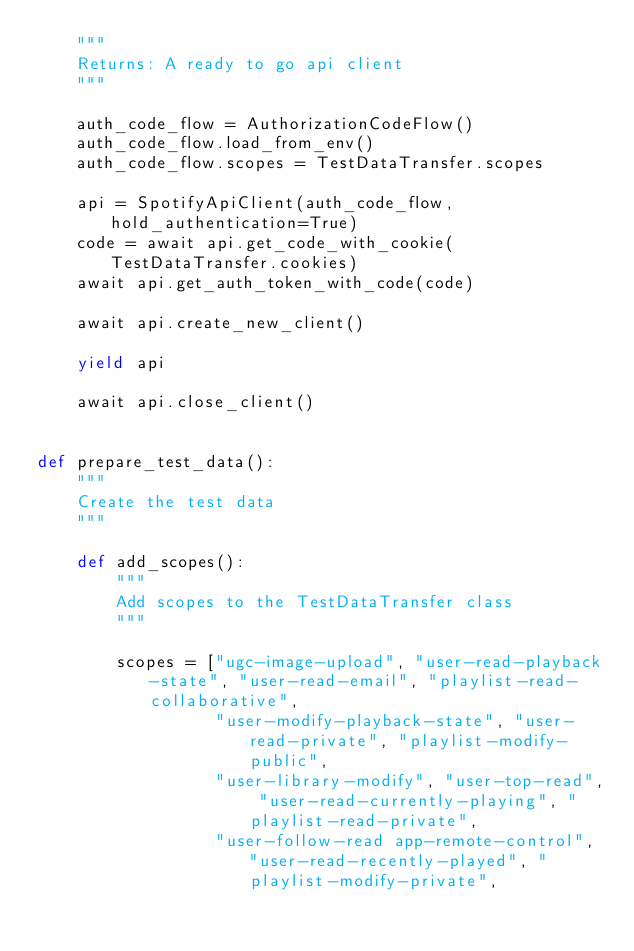<code> <loc_0><loc_0><loc_500><loc_500><_Python_>    """
    Returns: A ready to go api client
    """

    auth_code_flow = AuthorizationCodeFlow()
    auth_code_flow.load_from_env()
    auth_code_flow.scopes = TestDataTransfer.scopes

    api = SpotifyApiClient(auth_code_flow, hold_authentication=True)
    code = await api.get_code_with_cookie(TestDataTransfer.cookies)
    await api.get_auth_token_with_code(code)

    await api.create_new_client()

    yield api

    await api.close_client()


def prepare_test_data():
    """
    Create the test data
    """

    def add_scopes():
        """
        Add scopes to the TestDataTransfer class
        """

        scopes = ["ugc-image-upload", "user-read-playback-state", "user-read-email", "playlist-read-collaborative",
                  "user-modify-playback-state", "user-read-private", "playlist-modify-public",
                  "user-library-modify", "user-top-read", "user-read-currently-playing", "playlist-read-private",
                  "user-follow-read app-remote-control", "user-read-recently-played", "playlist-modify-private",</code> 